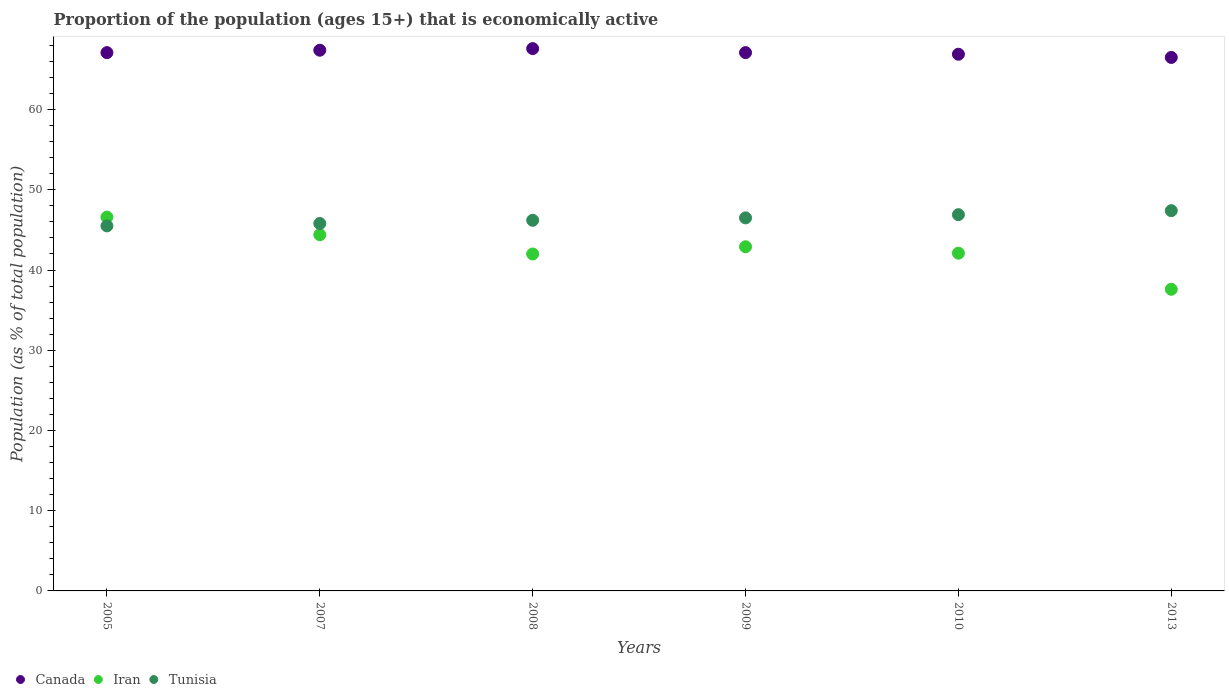How many different coloured dotlines are there?
Offer a terse response. 3. What is the proportion of the population that is economically active in Iran in 2010?
Your answer should be compact. 42.1. Across all years, what is the maximum proportion of the population that is economically active in Tunisia?
Give a very brief answer. 47.4. Across all years, what is the minimum proportion of the population that is economically active in Canada?
Ensure brevity in your answer.  66.5. In which year was the proportion of the population that is economically active in Iran maximum?
Offer a terse response. 2005. In which year was the proportion of the population that is economically active in Tunisia minimum?
Make the answer very short. 2005. What is the total proportion of the population that is economically active in Canada in the graph?
Ensure brevity in your answer.  402.6. What is the difference between the proportion of the population that is economically active in Iran in 2010 and that in 2013?
Make the answer very short. 4.5. What is the difference between the proportion of the population that is economically active in Tunisia in 2005 and the proportion of the population that is economically active in Iran in 2009?
Keep it short and to the point. 2.6. What is the average proportion of the population that is economically active in Tunisia per year?
Provide a succinct answer. 46.38. In the year 2007, what is the difference between the proportion of the population that is economically active in Canada and proportion of the population that is economically active in Tunisia?
Provide a succinct answer. 21.6. In how many years, is the proportion of the population that is economically active in Canada greater than 10 %?
Provide a short and direct response. 6. What is the ratio of the proportion of the population that is economically active in Tunisia in 2008 to that in 2009?
Provide a succinct answer. 0.99. Is the difference between the proportion of the population that is economically active in Canada in 2005 and 2008 greater than the difference between the proportion of the population that is economically active in Tunisia in 2005 and 2008?
Ensure brevity in your answer.  Yes. What is the difference between the highest and the second highest proportion of the population that is economically active in Tunisia?
Your answer should be very brief. 0.5. What is the difference between the highest and the lowest proportion of the population that is economically active in Canada?
Your answer should be very brief. 1.1. Is it the case that in every year, the sum of the proportion of the population that is economically active in Iran and proportion of the population that is economically active in Canada  is greater than the proportion of the population that is economically active in Tunisia?
Your answer should be compact. Yes. Is the proportion of the population that is economically active in Tunisia strictly less than the proportion of the population that is economically active in Iran over the years?
Your response must be concise. No. How many dotlines are there?
Your answer should be compact. 3. Does the graph contain any zero values?
Your answer should be compact. No. Where does the legend appear in the graph?
Your answer should be compact. Bottom left. How many legend labels are there?
Offer a terse response. 3. What is the title of the graph?
Offer a very short reply. Proportion of the population (ages 15+) that is economically active. What is the label or title of the X-axis?
Make the answer very short. Years. What is the label or title of the Y-axis?
Provide a succinct answer. Population (as % of total population). What is the Population (as % of total population) of Canada in 2005?
Offer a terse response. 67.1. What is the Population (as % of total population) in Iran in 2005?
Give a very brief answer. 46.6. What is the Population (as % of total population) of Tunisia in 2005?
Give a very brief answer. 45.5. What is the Population (as % of total population) of Canada in 2007?
Ensure brevity in your answer.  67.4. What is the Population (as % of total population) in Iran in 2007?
Provide a succinct answer. 44.4. What is the Population (as % of total population) of Tunisia in 2007?
Your answer should be very brief. 45.8. What is the Population (as % of total population) in Canada in 2008?
Ensure brevity in your answer.  67.6. What is the Population (as % of total population) of Tunisia in 2008?
Your answer should be very brief. 46.2. What is the Population (as % of total population) of Canada in 2009?
Your response must be concise. 67.1. What is the Population (as % of total population) in Iran in 2009?
Your answer should be compact. 42.9. What is the Population (as % of total population) of Tunisia in 2009?
Give a very brief answer. 46.5. What is the Population (as % of total population) of Canada in 2010?
Your answer should be very brief. 66.9. What is the Population (as % of total population) in Iran in 2010?
Provide a short and direct response. 42.1. What is the Population (as % of total population) in Tunisia in 2010?
Your response must be concise. 46.9. What is the Population (as % of total population) in Canada in 2013?
Your answer should be compact. 66.5. What is the Population (as % of total population) in Iran in 2013?
Keep it short and to the point. 37.6. What is the Population (as % of total population) in Tunisia in 2013?
Provide a short and direct response. 47.4. Across all years, what is the maximum Population (as % of total population) in Canada?
Offer a terse response. 67.6. Across all years, what is the maximum Population (as % of total population) in Iran?
Your answer should be compact. 46.6. Across all years, what is the maximum Population (as % of total population) in Tunisia?
Keep it short and to the point. 47.4. Across all years, what is the minimum Population (as % of total population) in Canada?
Your response must be concise. 66.5. Across all years, what is the minimum Population (as % of total population) in Iran?
Your response must be concise. 37.6. Across all years, what is the minimum Population (as % of total population) of Tunisia?
Keep it short and to the point. 45.5. What is the total Population (as % of total population) of Canada in the graph?
Provide a short and direct response. 402.6. What is the total Population (as % of total population) in Iran in the graph?
Make the answer very short. 255.6. What is the total Population (as % of total population) in Tunisia in the graph?
Offer a very short reply. 278.3. What is the difference between the Population (as % of total population) of Iran in 2005 and that in 2007?
Your answer should be very brief. 2.2. What is the difference between the Population (as % of total population) of Tunisia in 2005 and that in 2007?
Offer a terse response. -0.3. What is the difference between the Population (as % of total population) of Iran in 2005 and that in 2008?
Ensure brevity in your answer.  4.6. What is the difference between the Population (as % of total population) of Canada in 2005 and that in 2009?
Offer a terse response. 0. What is the difference between the Population (as % of total population) of Tunisia in 2005 and that in 2009?
Your response must be concise. -1. What is the difference between the Population (as % of total population) of Canada in 2005 and that in 2010?
Offer a very short reply. 0.2. What is the difference between the Population (as % of total population) of Iran in 2005 and that in 2013?
Offer a terse response. 9. What is the difference between the Population (as % of total population) of Iran in 2007 and that in 2009?
Offer a terse response. 1.5. What is the difference between the Population (as % of total population) of Tunisia in 2007 and that in 2009?
Provide a succinct answer. -0.7. What is the difference between the Population (as % of total population) of Canada in 2007 and that in 2010?
Your answer should be compact. 0.5. What is the difference between the Population (as % of total population) of Canada in 2007 and that in 2013?
Your answer should be very brief. 0.9. What is the difference between the Population (as % of total population) in Iran in 2007 and that in 2013?
Keep it short and to the point. 6.8. What is the difference between the Population (as % of total population) in Canada in 2008 and that in 2009?
Offer a terse response. 0.5. What is the difference between the Population (as % of total population) of Tunisia in 2008 and that in 2009?
Ensure brevity in your answer.  -0.3. What is the difference between the Population (as % of total population) of Canada in 2008 and that in 2010?
Make the answer very short. 0.7. What is the difference between the Population (as % of total population) of Tunisia in 2008 and that in 2013?
Keep it short and to the point. -1.2. What is the difference between the Population (as % of total population) in Iran in 2009 and that in 2010?
Ensure brevity in your answer.  0.8. What is the difference between the Population (as % of total population) of Iran in 2009 and that in 2013?
Your answer should be very brief. 5.3. What is the difference between the Population (as % of total population) of Canada in 2010 and that in 2013?
Your answer should be compact. 0.4. What is the difference between the Population (as % of total population) in Tunisia in 2010 and that in 2013?
Your answer should be compact. -0.5. What is the difference between the Population (as % of total population) in Canada in 2005 and the Population (as % of total population) in Iran in 2007?
Ensure brevity in your answer.  22.7. What is the difference between the Population (as % of total population) in Canada in 2005 and the Population (as % of total population) in Tunisia in 2007?
Keep it short and to the point. 21.3. What is the difference between the Population (as % of total population) in Iran in 2005 and the Population (as % of total population) in Tunisia in 2007?
Keep it short and to the point. 0.8. What is the difference between the Population (as % of total population) in Canada in 2005 and the Population (as % of total population) in Iran in 2008?
Your answer should be compact. 25.1. What is the difference between the Population (as % of total population) in Canada in 2005 and the Population (as % of total population) in Tunisia in 2008?
Keep it short and to the point. 20.9. What is the difference between the Population (as % of total population) in Canada in 2005 and the Population (as % of total population) in Iran in 2009?
Give a very brief answer. 24.2. What is the difference between the Population (as % of total population) in Canada in 2005 and the Population (as % of total population) in Tunisia in 2009?
Offer a very short reply. 20.6. What is the difference between the Population (as % of total population) in Canada in 2005 and the Population (as % of total population) in Iran in 2010?
Ensure brevity in your answer.  25. What is the difference between the Population (as % of total population) of Canada in 2005 and the Population (as % of total population) of Tunisia in 2010?
Your answer should be compact. 20.2. What is the difference between the Population (as % of total population) in Iran in 2005 and the Population (as % of total population) in Tunisia in 2010?
Your response must be concise. -0.3. What is the difference between the Population (as % of total population) of Canada in 2005 and the Population (as % of total population) of Iran in 2013?
Your response must be concise. 29.5. What is the difference between the Population (as % of total population) of Canada in 2005 and the Population (as % of total population) of Tunisia in 2013?
Your answer should be compact. 19.7. What is the difference between the Population (as % of total population) of Iran in 2005 and the Population (as % of total population) of Tunisia in 2013?
Your response must be concise. -0.8. What is the difference between the Population (as % of total population) of Canada in 2007 and the Population (as % of total population) of Iran in 2008?
Provide a short and direct response. 25.4. What is the difference between the Population (as % of total population) of Canada in 2007 and the Population (as % of total population) of Tunisia in 2008?
Provide a succinct answer. 21.2. What is the difference between the Population (as % of total population) in Iran in 2007 and the Population (as % of total population) in Tunisia in 2008?
Provide a short and direct response. -1.8. What is the difference between the Population (as % of total population) of Canada in 2007 and the Population (as % of total population) of Tunisia in 2009?
Ensure brevity in your answer.  20.9. What is the difference between the Population (as % of total population) in Iran in 2007 and the Population (as % of total population) in Tunisia in 2009?
Offer a terse response. -2.1. What is the difference between the Population (as % of total population) in Canada in 2007 and the Population (as % of total population) in Iran in 2010?
Provide a short and direct response. 25.3. What is the difference between the Population (as % of total population) of Canada in 2007 and the Population (as % of total population) of Iran in 2013?
Offer a very short reply. 29.8. What is the difference between the Population (as % of total population) of Canada in 2007 and the Population (as % of total population) of Tunisia in 2013?
Keep it short and to the point. 20. What is the difference between the Population (as % of total population) of Iran in 2007 and the Population (as % of total population) of Tunisia in 2013?
Offer a very short reply. -3. What is the difference between the Population (as % of total population) of Canada in 2008 and the Population (as % of total population) of Iran in 2009?
Your answer should be compact. 24.7. What is the difference between the Population (as % of total population) of Canada in 2008 and the Population (as % of total population) of Tunisia in 2009?
Give a very brief answer. 21.1. What is the difference between the Population (as % of total population) in Iran in 2008 and the Population (as % of total population) in Tunisia in 2009?
Give a very brief answer. -4.5. What is the difference between the Population (as % of total population) in Canada in 2008 and the Population (as % of total population) in Iran in 2010?
Make the answer very short. 25.5. What is the difference between the Population (as % of total population) of Canada in 2008 and the Population (as % of total population) of Tunisia in 2010?
Ensure brevity in your answer.  20.7. What is the difference between the Population (as % of total population) of Iran in 2008 and the Population (as % of total population) of Tunisia in 2010?
Provide a short and direct response. -4.9. What is the difference between the Population (as % of total population) of Canada in 2008 and the Population (as % of total population) of Iran in 2013?
Make the answer very short. 30. What is the difference between the Population (as % of total population) in Canada in 2008 and the Population (as % of total population) in Tunisia in 2013?
Ensure brevity in your answer.  20.2. What is the difference between the Population (as % of total population) of Iran in 2008 and the Population (as % of total population) of Tunisia in 2013?
Make the answer very short. -5.4. What is the difference between the Population (as % of total population) in Canada in 2009 and the Population (as % of total population) in Tunisia in 2010?
Ensure brevity in your answer.  20.2. What is the difference between the Population (as % of total population) of Iran in 2009 and the Population (as % of total population) of Tunisia in 2010?
Provide a short and direct response. -4. What is the difference between the Population (as % of total population) of Canada in 2009 and the Population (as % of total population) of Iran in 2013?
Your response must be concise. 29.5. What is the difference between the Population (as % of total population) in Canada in 2009 and the Population (as % of total population) in Tunisia in 2013?
Offer a very short reply. 19.7. What is the difference between the Population (as % of total population) of Iran in 2009 and the Population (as % of total population) of Tunisia in 2013?
Provide a short and direct response. -4.5. What is the difference between the Population (as % of total population) in Canada in 2010 and the Population (as % of total population) in Iran in 2013?
Provide a short and direct response. 29.3. What is the difference between the Population (as % of total population) in Iran in 2010 and the Population (as % of total population) in Tunisia in 2013?
Make the answer very short. -5.3. What is the average Population (as % of total population) in Canada per year?
Provide a short and direct response. 67.1. What is the average Population (as % of total population) of Iran per year?
Your response must be concise. 42.6. What is the average Population (as % of total population) in Tunisia per year?
Provide a short and direct response. 46.38. In the year 2005, what is the difference between the Population (as % of total population) of Canada and Population (as % of total population) of Tunisia?
Your answer should be compact. 21.6. In the year 2007, what is the difference between the Population (as % of total population) in Canada and Population (as % of total population) in Tunisia?
Your response must be concise. 21.6. In the year 2007, what is the difference between the Population (as % of total population) in Iran and Population (as % of total population) in Tunisia?
Make the answer very short. -1.4. In the year 2008, what is the difference between the Population (as % of total population) in Canada and Population (as % of total population) in Iran?
Provide a short and direct response. 25.6. In the year 2008, what is the difference between the Population (as % of total population) in Canada and Population (as % of total population) in Tunisia?
Offer a terse response. 21.4. In the year 2009, what is the difference between the Population (as % of total population) in Canada and Population (as % of total population) in Iran?
Provide a short and direct response. 24.2. In the year 2009, what is the difference between the Population (as % of total population) in Canada and Population (as % of total population) in Tunisia?
Give a very brief answer. 20.6. In the year 2009, what is the difference between the Population (as % of total population) in Iran and Population (as % of total population) in Tunisia?
Your answer should be compact. -3.6. In the year 2010, what is the difference between the Population (as % of total population) of Canada and Population (as % of total population) of Iran?
Give a very brief answer. 24.8. In the year 2010, what is the difference between the Population (as % of total population) in Canada and Population (as % of total population) in Tunisia?
Your answer should be very brief. 20. In the year 2010, what is the difference between the Population (as % of total population) of Iran and Population (as % of total population) of Tunisia?
Provide a succinct answer. -4.8. In the year 2013, what is the difference between the Population (as % of total population) in Canada and Population (as % of total population) in Iran?
Offer a very short reply. 28.9. What is the ratio of the Population (as % of total population) in Iran in 2005 to that in 2007?
Ensure brevity in your answer.  1.05. What is the ratio of the Population (as % of total population) of Iran in 2005 to that in 2008?
Provide a succinct answer. 1.11. What is the ratio of the Population (as % of total population) of Iran in 2005 to that in 2009?
Your answer should be compact. 1.09. What is the ratio of the Population (as % of total population) in Tunisia in 2005 to that in 2009?
Offer a terse response. 0.98. What is the ratio of the Population (as % of total population) of Canada in 2005 to that in 2010?
Keep it short and to the point. 1. What is the ratio of the Population (as % of total population) of Iran in 2005 to that in 2010?
Your response must be concise. 1.11. What is the ratio of the Population (as % of total population) in Tunisia in 2005 to that in 2010?
Make the answer very short. 0.97. What is the ratio of the Population (as % of total population) in Iran in 2005 to that in 2013?
Provide a short and direct response. 1.24. What is the ratio of the Population (as % of total population) of Tunisia in 2005 to that in 2013?
Offer a very short reply. 0.96. What is the ratio of the Population (as % of total population) in Canada in 2007 to that in 2008?
Offer a terse response. 1. What is the ratio of the Population (as % of total population) in Iran in 2007 to that in 2008?
Keep it short and to the point. 1.06. What is the ratio of the Population (as % of total population) in Iran in 2007 to that in 2009?
Your response must be concise. 1.03. What is the ratio of the Population (as % of total population) of Tunisia in 2007 to that in 2009?
Your response must be concise. 0.98. What is the ratio of the Population (as % of total population) in Canada in 2007 to that in 2010?
Offer a terse response. 1.01. What is the ratio of the Population (as % of total population) in Iran in 2007 to that in 2010?
Give a very brief answer. 1.05. What is the ratio of the Population (as % of total population) in Tunisia in 2007 to that in 2010?
Provide a short and direct response. 0.98. What is the ratio of the Population (as % of total population) in Canada in 2007 to that in 2013?
Give a very brief answer. 1.01. What is the ratio of the Population (as % of total population) of Iran in 2007 to that in 2013?
Keep it short and to the point. 1.18. What is the ratio of the Population (as % of total population) of Tunisia in 2007 to that in 2013?
Offer a terse response. 0.97. What is the ratio of the Population (as % of total population) in Canada in 2008 to that in 2009?
Your response must be concise. 1.01. What is the ratio of the Population (as % of total population) of Iran in 2008 to that in 2009?
Your answer should be very brief. 0.98. What is the ratio of the Population (as % of total population) of Tunisia in 2008 to that in 2009?
Make the answer very short. 0.99. What is the ratio of the Population (as % of total population) in Canada in 2008 to that in 2010?
Make the answer very short. 1.01. What is the ratio of the Population (as % of total population) of Iran in 2008 to that in 2010?
Provide a short and direct response. 1. What is the ratio of the Population (as % of total population) of Tunisia in 2008 to that in 2010?
Your response must be concise. 0.99. What is the ratio of the Population (as % of total population) of Canada in 2008 to that in 2013?
Give a very brief answer. 1.02. What is the ratio of the Population (as % of total population) in Iran in 2008 to that in 2013?
Keep it short and to the point. 1.12. What is the ratio of the Population (as % of total population) in Tunisia in 2008 to that in 2013?
Offer a terse response. 0.97. What is the ratio of the Population (as % of total population) of Iran in 2009 to that in 2010?
Provide a short and direct response. 1.02. What is the ratio of the Population (as % of total population) in Canada in 2009 to that in 2013?
Keep it short and to the point. 1.01. What is the ratio of the Population (as % of total population) in Iran in 2009 to that in 2013?
Provide a succinct answer. 1.14. What is the ratio of the Population (as % of total population) in Tunisia in 2009 to that in 2013?
Your answer should be very brief. 0.98. What is the ratio of the Population (as % of total population) in Canada in 2010 to that in 2013?
Make the answer very short. 1.01. What is the ratio of the Population (as % of total population) of Iran in 2010 to that in 2013?
Your response must be concise. 1.12. What is the ratio of the Population (as % of total population) in Tunisia in 2010 to that in 2013?
Your answer should be very brief. 0.99. What is the difference between the highest and the second highest Population (as % of total population) of Canada?
Offer a very short reply. 0.2. What is the difference between the highest and the second highest Population (as % of total population) in Iran?
Offer a very short reply. 2.2. What is the difference between the highest and the lowest Population (as % of total population) of Canada?
Provide a short and direct response. 1.1. What is the difference between the highest and the lowest Population (as % of total population) in Iran?
Offer a terse response. 9. What is the difference between the highest and the lowest Population (as % of total population) in Tunisia?
Provide a succinct answer. 1.9. 